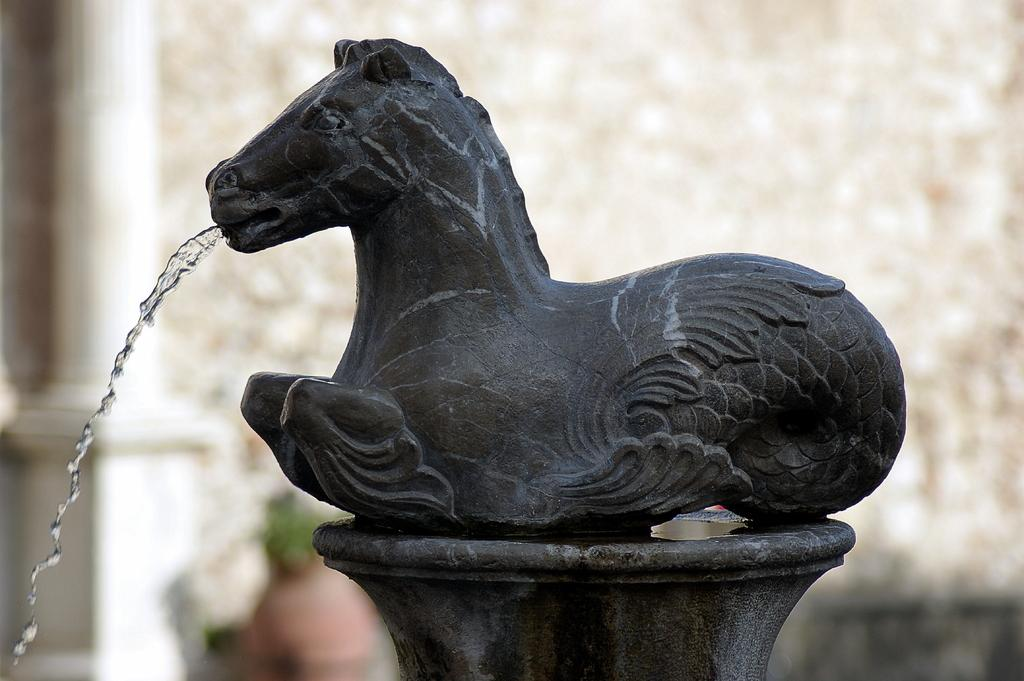What is the main subject of the image? There is a statue of an animal in the image. What is the statue of the animal doing? Water is falling down from the mouth of the animal statue. What type of relation does the chair have with the animal statue in the image? There is no chair present in the image, so it cannot have any relation with the animal statue. 